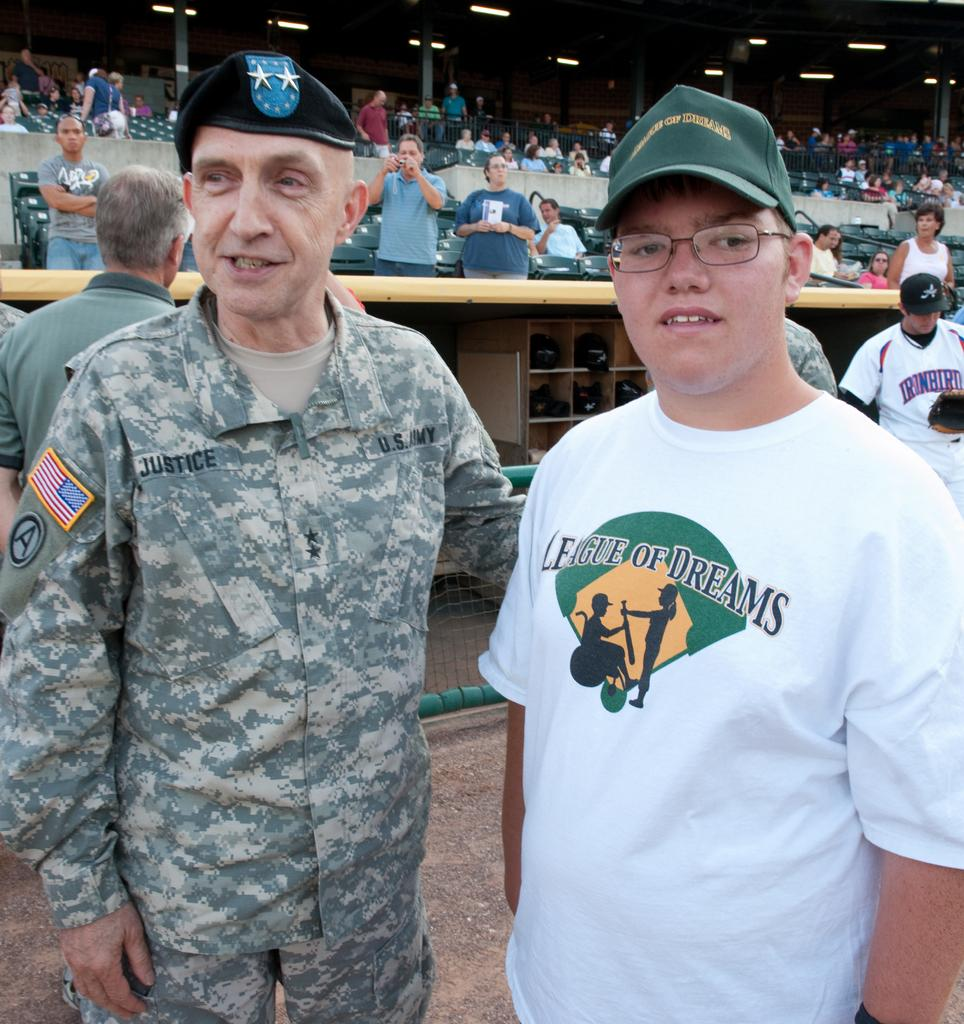<image>
Describe the image concisely. an army man standing next to a boy wearing a shirt that says 'league of dreams' 